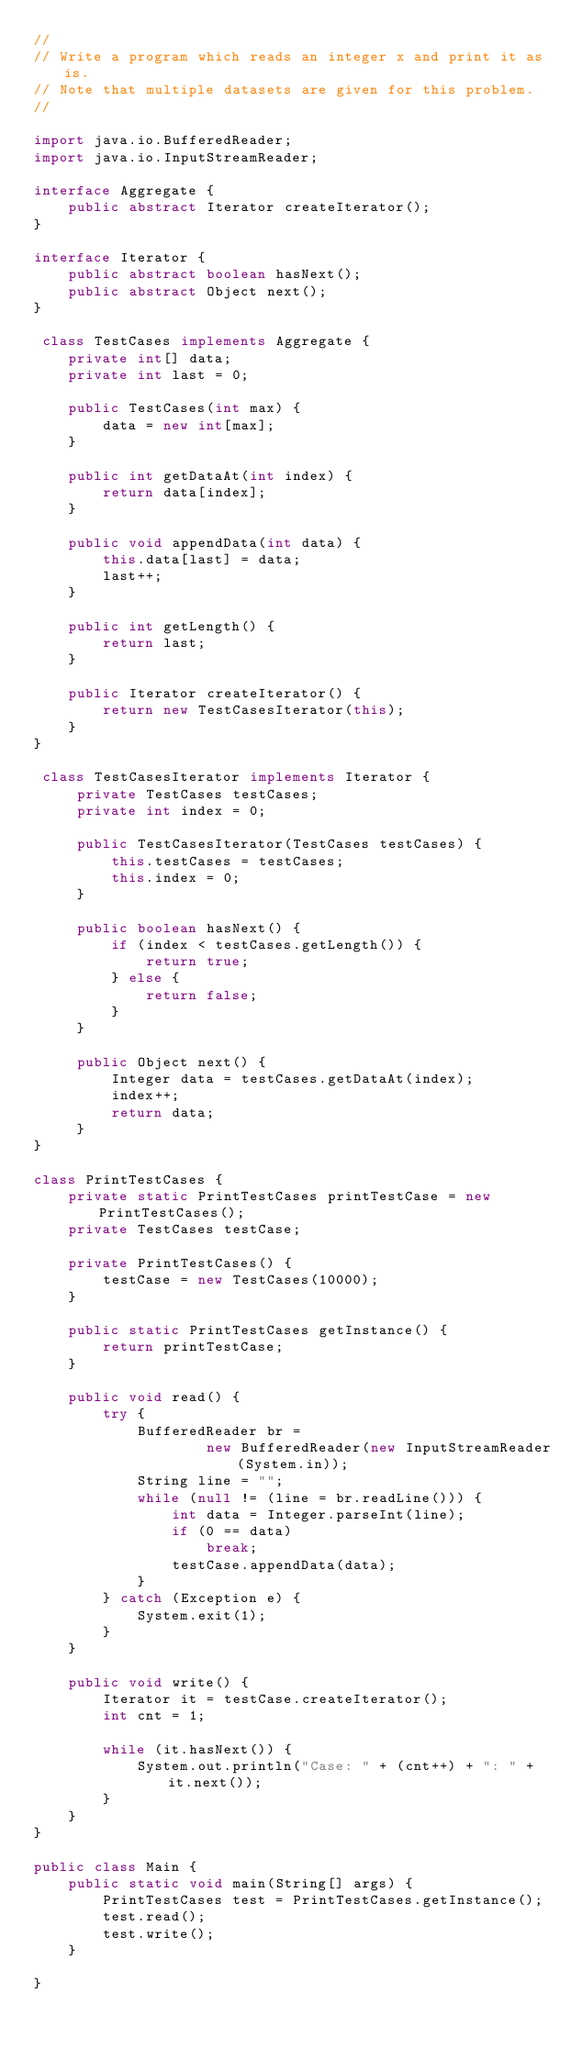Convert code to text. <code><loc_0><loc_0><loc_500><loc_500><_Java_>//
// Write a program which reads an integer x and print it as is.
// Note that multiple datasets are given for this problem.
//

import java.io.BufferedReader;
import java.io.InputStreamReader;

interface Aggregate {
	public abstract Iterator createIterator();
}

interface Iterator {
	public abstract boolean hasNext();
	public abstract Object next();
}

 class TestCases implements Aggregate {
	private int[] data;
	private int last = 0;
	
	public TestCases(int max) {
		data = new int[max];
	}
	
	public int getDataAt(int index) {
		return data[index];
	}
	
	public void appendData(int data) {
		this.data[last] = data;
		last++;
	}
	
	public int getLength() {
		return last;
	}
	
	public Iterator createIterator() {
		return new TestCasesIterator(this);
	}
}
 
 class TestCasesIterator implements Iterator {
	 private TestCases testCases;
	 private int index = 0;
	 
	 public TestCasesIterator(TestCases testCases) {
		 this.testCases = testCases;
		 this.index = 0;
	 }
	 
	 public boolean hasNext() {
		 if (index < testCases.getLength()) {
			 return true;
		 } else {
			 return false;
		 }
	 }
	 
	 public Object next() {
		 Integer data = testCases.getDataAt(index);
		 index++;
		 return data;
	 }
}

class PrintTestCases {
	private static PrintTestCases printTestCase = new PrintTestCases();
	private TestCases testCase;
	
	private PrintTestCases() {
		testCase = new TestCases(10000);
	}
	
	public static PrintTestCases getInstance() {
		return printTestCase;
	}
	
	public void read() {
		try {
			BufferedReader br =
					new BufferedReader(new InputStreamReader(System.in));
			String line = "";
			while (null != (line = br.readLine())) {
				int data = Integer.parseInt(line);
				if (0 == data)
					break;
				testCase.appendData(data);
			}
		} catch (Exception e) {
			System.exit(1);
		}
	}
	
	public void write() {
		Iterator it = testCase.createIterator();
		int cnt = 1;
		
		while (it.hasNext()) {
			System.out.println("Case: " + (cnt++) + ": " + it.next());
		}
	}
}

public class Main {
	public static void main(String[] args) {
		PrintTestCases test = PrintTestCases.getInstance();
		test.read();
		test.write();
	}

}</code> 